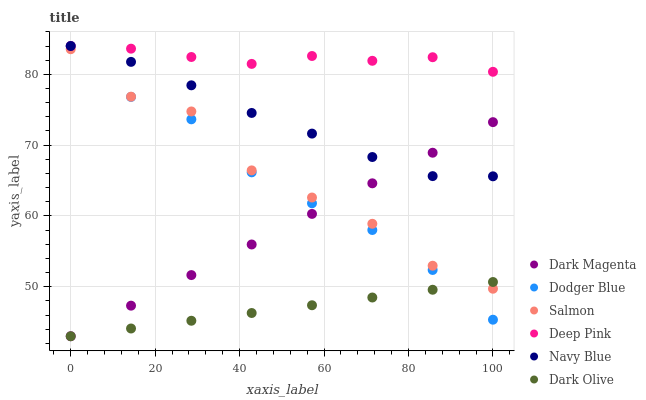Does Dark Olive have the minimum area under the curve?
Answer yes or no. Yes. Does Deep Pink have the maximum area under the curve?
Answer yes or no. Yes. Does Dark Magenta have the minimum area under the curve?
Answer yes or no. No. Does Dark Magenta have the maximum area under the curve?
Answer yes or no. No. Is Dark Olive the smoothest?
Answer yes or no. Yes. Is Salmon the roughest?
Answer yes or no. Yes. Is Dark Magenta the smoothest?
Answer yes or no. No. Is Dark Magenta the roughest?
Answer yes or no. No. Does Dark Magenta have the lowest value?
Answer yes or no. Yes. Does Navy Blue have the lowest value?
Answer yes or no. No. Does Dodger Blue have the highest value?
Answer yes or no. Yes. Does Dark Magenta have the highest value?
Answer yes or no. No. Is Salmon less than Deep Pink?
Answer yes or no. Yes. Is Deep Pink greater than Salmon?
Answer yes or no. Yes. Does Dark Olive intersect Dark Magenta?
Answer yes or no. Yes. Is Dark Olive less than Dark Magenta?
Answer yes or no. No. Is Dark Olive greater than Dark Magenta?
Answer yes or no. No. Does Salmon intersect Deep Pink?
Answer yes or no. No. 